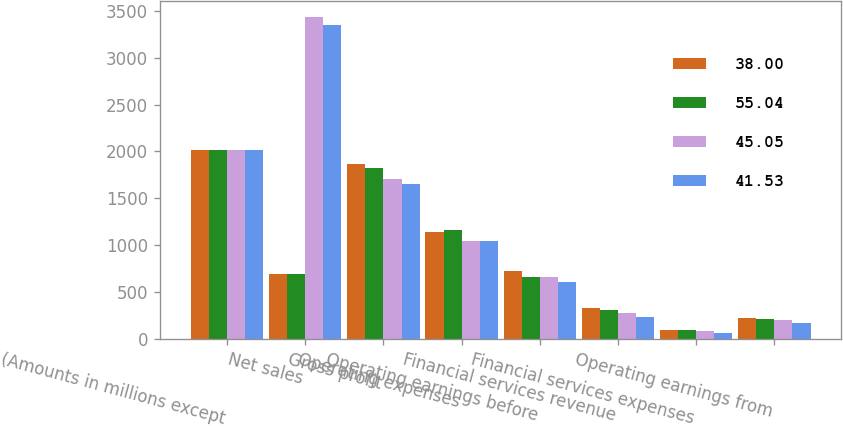Convert chart. <chart><loc_0><loc_0><loc_500><loc_500><stacked_bar_chart><ecel><fcel>(Amounts in millions except<fcel>Net sales<fcel>Gross profit<fcel>Operating expenses<fcel>Operating earnings before<fcel>Financial services revenue<fcel>Financial services expenses<fcel>Operating earnings from<nl><fcel>38<fcel>2018<fcel>695.3<fcel>1870<fcel>1144<fcel>726<fcel>329.7<fcel>99.6<fcel>230.1<nl><fcel>55.04<fcel>2017<fcel>695.3<fcel>1825.9<fcel>1161.3<fcel>664.6<fcel>313.4<fcel>95.9<fcel>217.5<nl><fcel>45.05<fcel>2016<fcel>3430.4<fcel>1710.4<fcel>1048<fcel>662.4<fcel>281.4<fcel>82.7<fcel>198.7<nl><fcel>41.53<fcel>2015<fcel>3352.8<fcel>1649.3<fcel>1041.3<fcel>608<fcel>240.3<fcel>70.1<fcel>170.2<nl></chart> 